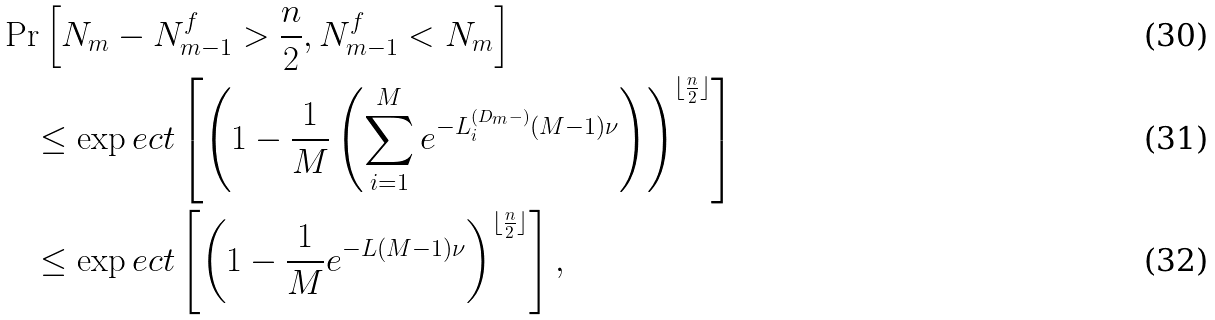<formula> <loc_0><loc_0><loc_500><loc_500>& \Pr \left [ N _ { m } - N ^ { f } _ { m - 1 } > \frac { n } { 2 } , N ^ { f } _ { m - 1 } < N _ { m } \right ] \\ & \quad \leq \exp e c t \left [ \left ( 1 - \frac { 1 } { M } \left ( \sum _ { i = 1 } ^ { M } e ^ { - L _ { i } ^ { ( D _ { m } - ) } ( M - 1 ) \nu } \right ) \right ) ^ { \lfloor \frac { n } { 2 } \rfloor } \right ] \\ & \quad \leq \exp e c t \left [ \left ( 1 - \frac { 1 } { M } e ^ { - L ( M - 1 ) \nu } \right ) ^ { \lfloor \frac { n } { 2 } \rfloor } \right ] ,</formula> 